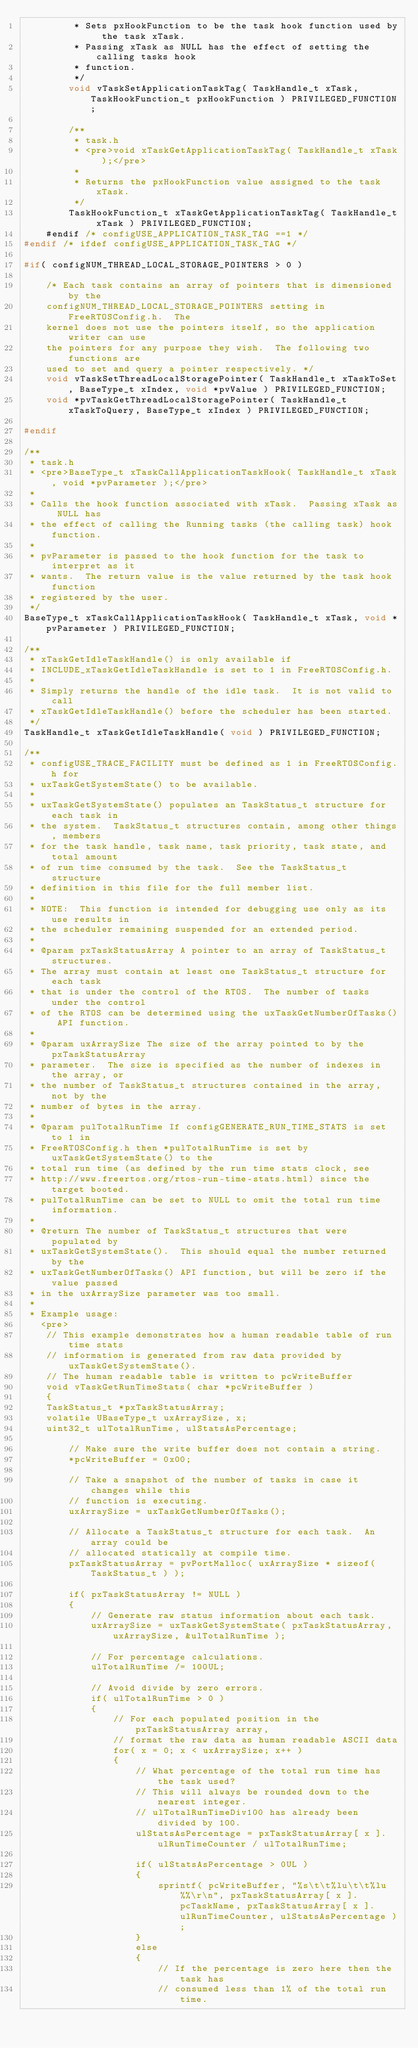<code> <loc_0><loc_0><loc_500><loc_500><_C_>         * Sets pxHookFunction to be the task hook function used by the task xTask.
         * Passing xTask as NULL has the effect of setting the calling tasks hook
         * function.
         */
        void vTaskSetApplicationTaskTag( TaskHandle_t xTask, TaskHookFunction_t pxHookFunction ) PRIVILEGED_FUNCTION;

        /**
         * task.h
         * <pre>void xTaskGetApplicationTaskTag( TaskHandle_t xTask );</pre>
         *
         * Returns the pxHookFunction value assigned to the task xTask.
         */
        TaskHookFunction_t xTaskGetApplicationTaskTag( TaskHandle_t xTask ) PRIVILEGED_FUNCTION;
    #endif /* configUSE_APPLICATION_TASK_TAG ==1 */
#endif /* ifdef configUSE_APPLICATION_TASK_TAG */

#if( configNUM_THREAD_LOCAL_STORAGE_POINTERS > 0 )

    /* Each task contains an array of pointers that is dimensioned by the
    configNUM_THREAD_LOCAL_STORAGE_POINTERS setting in FreeRTOSConfig.h.  The
    kernel does not use the pointers itself, so the application writer can use
    the pointers for any purpose they wish.  The following two functions are
    used to set and query a pointer respectively. */
    void vTaskSetThreadLocalStoragePointer( TaskHandle_t xTaskToSet, BaseType_t xIndex, void *pvValue ) PRIVILEGED_FUNCTION;
    void *pvTaskGetThreadLocalStoragePointer( TaskHandle_t xTaskToQuery, BaseType_t xIndex ) PRIVILEGED_FUNCTION;

#endif

/**
 * task.h
 * <pre>BaseType_t xTaskCallApplicationTaskHook( TaskHandle_t xTask, void *pvParameter );</pre>
 *
 * Calls the hook function associated with xTask.  Passing xTask as NULL has
 * the effect of calling the Running tasks (the calling task) hook function.
 *
 * pvParameter is passed to the hook function for the task to interpret as it
 * wants.  The return value is the value returned by the task hook function
 * registered by the user.
 */
BaseType_t xTaskCallApplicationTaskHook( TaskHandle_t xTask, void *pvParameter ) PRIVILEGED_FUNCTION;

/**
 * xTaskGetIdleTaskHandle() is only available if
 * INCLUDE_xTaskGetIdleTaskHandle is set to 1 in FreeRTOSConfig.h.
 *
 * Simply returns the handle of the idle task.  It is not valid to call
 * xTaskGetIdleTaskHandle() before the scheduler has been started.
 */
TaskHandle_t xTaskGetIdleTaskHandle( void ) PRIVILEGED_FUNCTION;

/**
 * configUSE_TRACE_FACILITY must be defined as 1 in FreeRTOSConfig.h for
 * uxTaskGetSystemState() to be available.
 *
 * uxTaskGetSystemState() populates an TaskStatus_t structure for each task in
 * the system.  TaskStatus_t structures contain, among other things, members
 * for the task handle, task name, task priority, task state, and total amount
 * of run time consumed by the task.  See the TaskStatus_t structure
 * definition in this file for the full member list.
 *
 * NOTE:  This function is intended for debugging use only as its use results in
 * the scheduler remaining suspended for an extended period.
 *
 * @param pxTaskStatusArray A pointer to an array of TaskStatus_t structures.
 * The array must contain at least one TaskStatus_t structure for each task
 * that is under the control of the RTOS.  The number of tasks under the control
 * of the RTOS can be determined using the uxTaskGetNumberOfTasks() API function.
 *
 * @param uxArraySize The size of the array pointed to by the pxTaskStatusArray
 * parameter.  The size is specified as the number of indexes in the array, or
 * the number of TaskStatus_t structures contained in the array, not by the
 * number of bytes in the array.
 *
 * @param pulTotalRunTime If configGENERATE_RUN_TIME_STATS is set to 1 in
 * FreeRTOSConfig.h then *pulTotalRunTime is set by uxTaskGetSystemState() to the
 * total run time (as defined by the run time stats clock, see
 * http://www.freertos.org/rtos-run-time-stats.html) since the target booted.
 * pulTotalRunTime can be set to NULL to omit the total run time information.
 *
 * @return The number of TaskStatus_t structures that were populated by
 * uxTaskGetSystemState().  This should equal the number returned by the
 * uxTaskGetNumberOfTasks() API function, but will be zero if the value passed
 * in the uxArraySize parameter was too small.
 *
 * Example usage:
   <pre>
    // This example demonstrates how a human readable table of run time stats
    // information is generated from raw data provided by uxTaskGetSystemState().
    // The human readable table is written to pcWriteBuffer
    void vTaskGetRunTimeStats( char *pcWriteBuffer )
    {
    TaskStatus_t *pxTaskStatusArray;
    volatile UBaseType_t uxArraySize, x;
    uint32_t ulTotalRunTime, ulStatsAsPercentage;

        // Make sure the write buffer does not contain a string.
        *pcWriteBuffer = 0x00;

        // Take a snapshot of the number of tasks in case it changes while this
        // function is executing.
        uxArraySize = uxTaskGetNumberOfTasks();

        // Allocate a TaskStatus_t structure for each task.  An array could be
        // allocated statically at compile time.
        pxTaskStatusArray = pvPortMalloc( uxArraySize * sizeof( TaskStatus_t ) );

        if( pxTaskStatusArray != NULL )
        {
            // Generate raw status information about each task.
            uxArraySize = uxTaskGetSystemState( pxTaskStatusArray, uxArraySize, &ulTotalRunTime );

            // For percentage calculations.
            ulTotalRunTime /= 100UL;

            // Avoid divide by zero errors.
            if( ulTotalRunTime > 0 )
            {
                // For each populated position in the pxTaskStatusArray array,
                // format the raw data as human readable ASCII data
                for( x = 0; x < uxArraySize; x++ )
                {
                    // What percentage of the total run time has the task used?
                    // This will always be rounded down to the nearest integer.
                    // ulTotalRunTimeDiv100 has already been divided by 100.
                    ulStatsAsPercentage = pxTaskStatusArray[ x ].ulRunTimeCounter / ulTotalRunTime;

                    if( ulStatsAsPercentage > 0UL )
                    {
                        sprintf( pcWriteBuffer, "%s\t\t%lu\t\t%lu%%\r\n", pxTaskStatusArray[ x ].pcTaskName, pxTaskStatusArray[ x ].ulRunTimeCounter, ulStatsAsPercentage );
                    }
                    else
                    {
                        // If the percentage is zero here then the task has
                        // consumed less than 1% of the total run time.</code> 